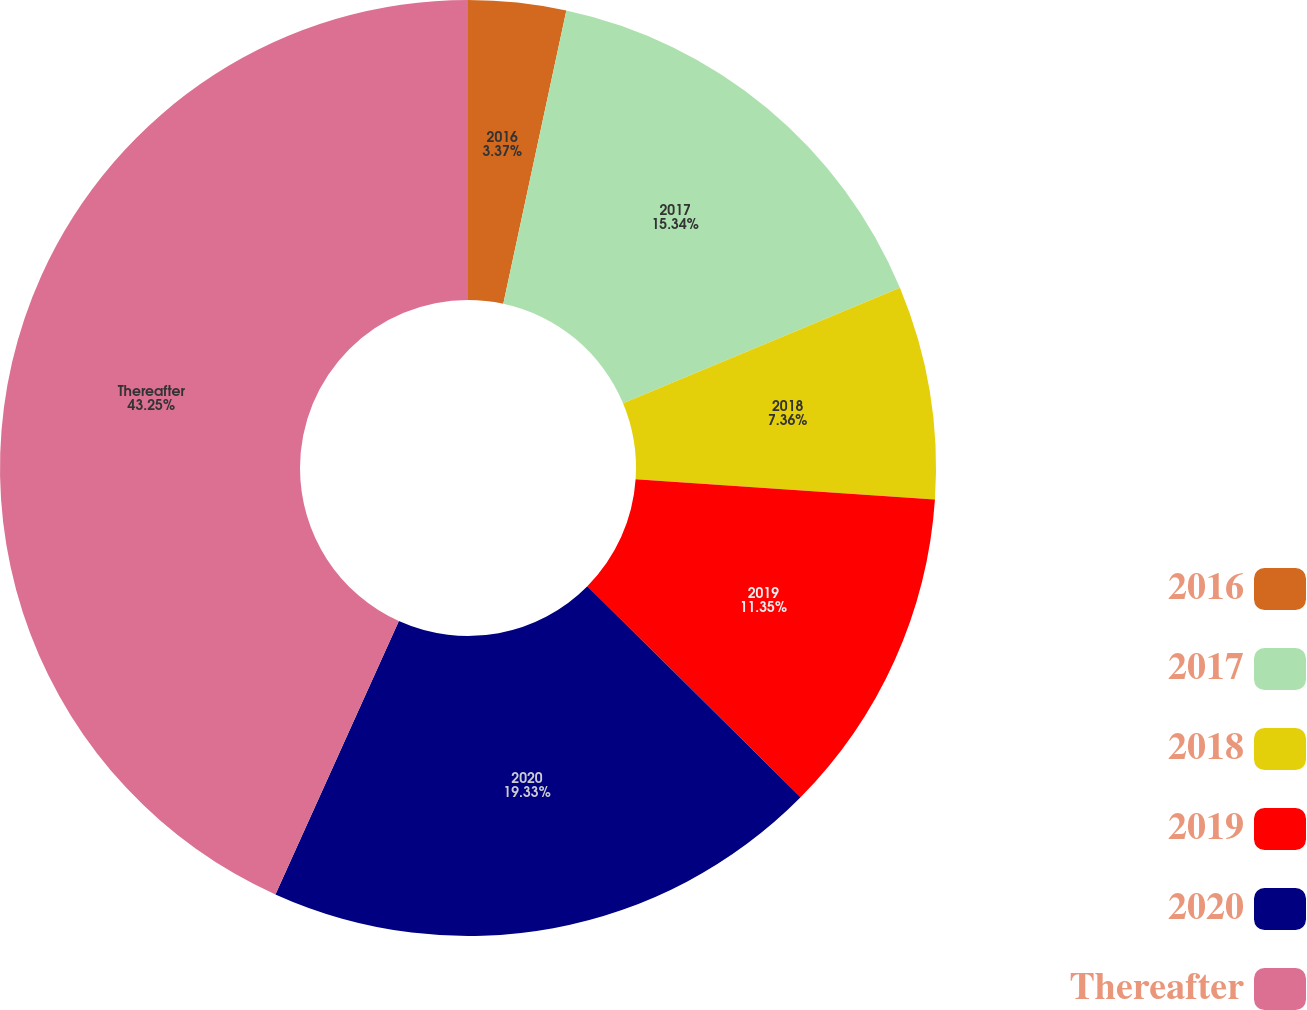Convert chart to OTSL. <chart><loc_0><loc_0><loc_500><loc_500><pie_chart><fcel>2016<fcel>2017<fcel>2018<fcel>2019<fcel>2020<fcel>Thereafter<nl><fcel>3.37%<fcel>15.34%<fcel>7.36%<fcel>11.35%<fcel>19.33%<fcel>43.25%<nl></chart> 